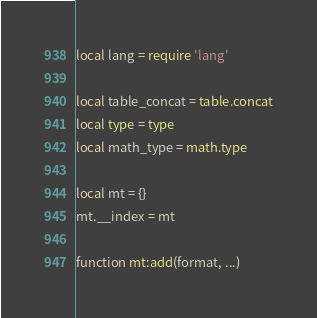<code> <loc_0><loc_0><loc_500><loc_500><_Lua_>local lang = require 'lang'

local table_concat = table.concat
local type = type
local math_type = math.type

local mt = {}
mt.__index = mt

function mt:add(format, ...)</code> 